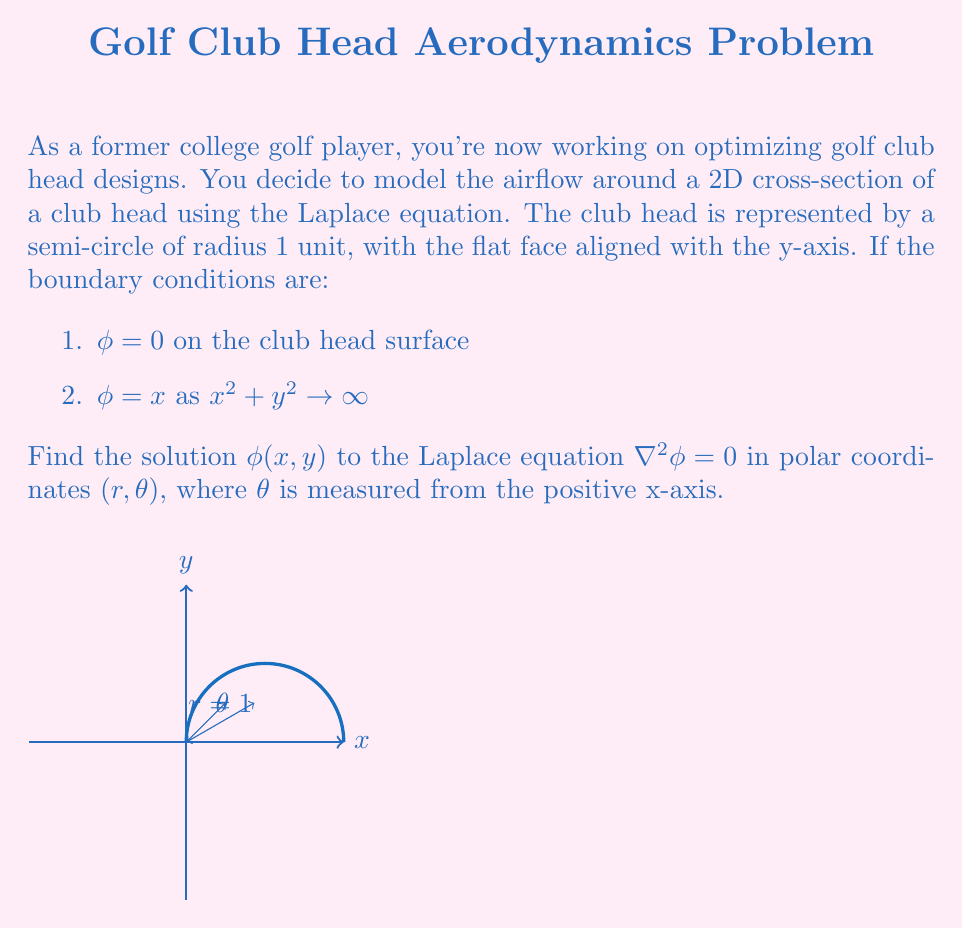Provide a solution to this math problem. Let's solve this step-by-step:

1) The Laplace equation in polar coordinates is:

   $$\frac{1}{r}\frac{\partial}{\partial r}\left(r\frac{\partial \phi}{\partial r}\right) + \frac{1}{r^2}\frac{\partial^2 \phi}{\partial \theta^2} = 0$$

2) Given the symmetry of the problem, we can use the method of separation of variables. Let $\phi(r,\theta) = R(r)\Theta(\theta)$.

3) Substituting this into the Laplace equation and dividing by $R\Theta$, we get:

   $$\frac{1}{rR}\frac{d}{dr}\left(r\frac{dR}{dr}\right) = -\frac{1}{r^2\Theta}\frac{d^2\Theta}{d\theta^2}$$

4) Since the left side depends only on $r$ and the right side only on $\theta$, both must equal a constant, say $n^2$:

   $$\frac{1}{R}\frac{d}{dr}\left(r\frac{dR}{dr}\right) = \frac{n^2}{r}$$
   $$\frac{d^2\Theta}{d\theta^2} = -n^2\Theta$$

5) The general solutions are:
   
   $$R(r) = Ar^n + Br^{-n}$$
   $$\Theta(\theta) = C\cos(n\theta) + D\sin(n\theta)$$

6) Given the boundary condition $\phi = x = r\cos\theta$ as $r \to \infty$, we must have $n=1$.

7) The general solution is thus:

   $$\phi(r,\theta) = (Ar + \frac{B}{r})(C\cos\theta + D\sin\theta)$$

8) Applying the boundary condition at infinity:

   $$\phi \to r\cos\theta \text{ as } r \to \infty$$

   This implies $A=1$, $C=1$, and $D=0$.

9) Now, applying the boundary condition on the club head surface $(r=1, 0 \leq \theta \leq \pi)$:

   $$0 = (1 + B)\cos\theta$$

   This implies $B = -1$.

10) Therefore, the final solution is:

    $$\phi(r,\theta) = (r - \frac{1}{r})\cos\theta$$
Answer: $\phi(r,\theta) = (r - \frac{1}{r})\cos\theta$ 